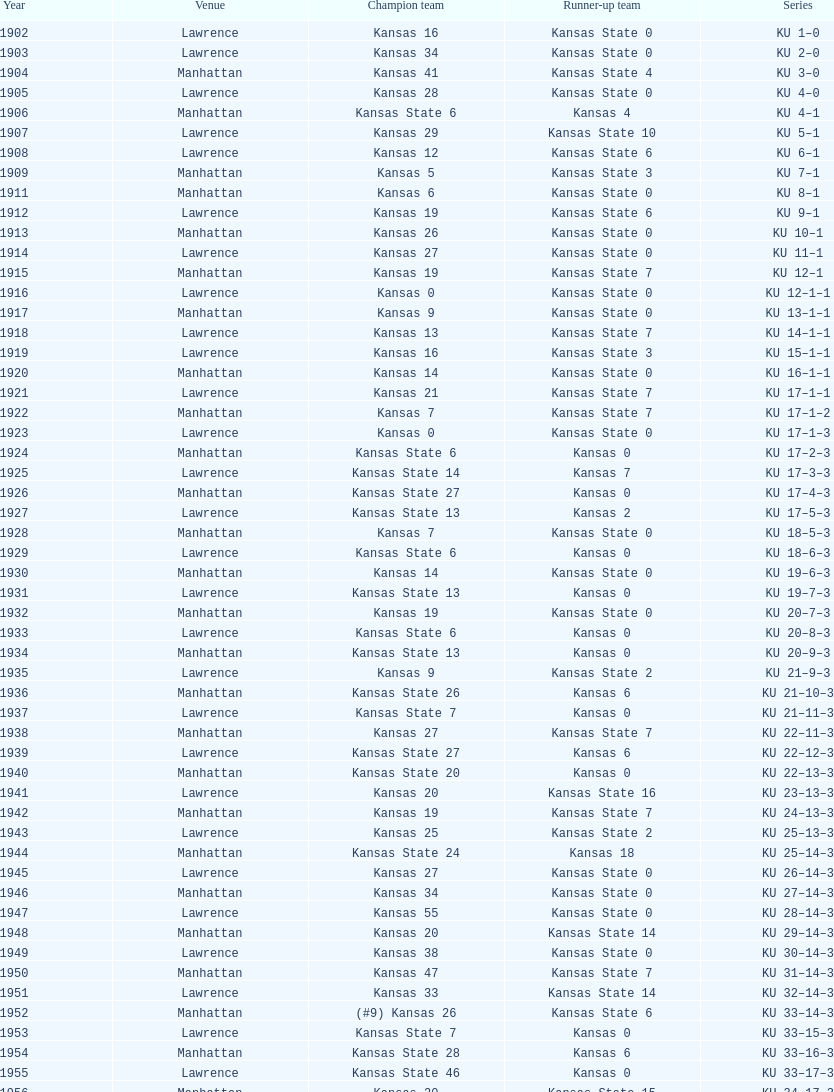Write the full table. {'header': ['Year', 'Venue', 'Champion team', 'Runner-up team', 'Series'], 'rows': [['1902', 'Lawrence', 'Kansas 16', 'Kansas State 0', 'KU 1–0'], ['1903', 'Lawrence', 'Kansas 34', 'Kansas State 0', 'KU 2–0'], ['1904', 'Manhattan', 'Kansas 41', 'Kansas State 4', 'KU 3–0'], ['1905', 'Lawrence', 'Kansas 28', 'Kansas State 0', 'KU 4–0'], ['1906', 'Manhattan', 'Kansas State 6', 'Kansas 4', 'KU 4–1'], ['1907', 'Lawrence', 'Kansas 29', 'Kansas State 10', 'KU 5–1'], ['1908', 'Lawrence', 'Kansas 12', 'Kansas State 6', 'KU 6–1'], ['1909', 'Manhattan', 'Kansas 5', 'Kansas State 3', 'KU 7–1'], ['1911', 'Manhattan', 'Kansas 6', 'Kansas State 0', 'KU 8–1'], ['1912', 'Lawrence', 'Kansas 19', 'Kansas State 6', 'KU 9–1'], ['1913', 'Manhattan', 'Kansas 26', 'Kansas State 0', 'KU 10–1'], ['1914', 'Lawrence', 'Kansas 27', 'Kansas State 0', 'KU 11–1'], ['1915', 'Manhattan', 'Kansas 19', 'Kansas State 7', 'KU 12–1'], ['1916', 'Lawrence', 'Kansas 0', 'Kansas State 0', 'KU 12–1–1'], ['1917', 'Manhattan', 'Kansas 9', 'Kansas State 0', 'KU 13–1–1'], ['1918', 'Lawrence', 'Kansas 13', 'Kansas State 7', 'KU 14–1–1'], ['1919', 'Lawrence', 'Kansas 16', 'Kansas State 3', 'KU 15–1–1'], ['1920', 'Manhattan', 'Kansas 14', 'Kansas State 0', 'KU 16–1–1'], ['1921', 'Lawrence', 'Kansas 21', 'Kansas State 7', 'KU 17–1–1'], ['1922', 'Manhattan', 'Kansas 7', 'Kansas State 7', 'KU 17–1–2'], ['1923', 'Lawrence', 'Kansas 0', 'Kansas State 0', 'KU 17–1–3'], ['1924', 'Manhattan', 'Kansas State 6', 'Kansas 0', 'KU 17–2–3'], ['1925', 'Lawrence', 'Kansas State 14', 'Kansas 7', 'KU 17–3–3'], ['1926', 'Manhattan', 'Kansas State 27', 'Kansas 0', 'KU 17–4–3'], ['1927', 'Lawrence', 'Kansas State 13', 'Kansas 2', 'KU 17–5–3'], ['1928', 'Manhattan', 'Kansas 7', 'Kansas State 0', 'KU 18–5–3'], ['1929', 'Lawrence', 'Kansas State 6', 'Kansas 0', 'KU 18–6–3'], ['1930', 'Manhattan', 'Kansas 14', 'Kansas State 0', 'KU 19–6–3'], ['1931', 'Lawrence', 'Kansas State 13', 'Kansas 0', 'KU 19–7–3'], ['1932', 'Manhattan', 'Kansas 19', 'Kansas State 0', 'KU 20–7–3'], ['1933', 'Lawrence', 'Kansas State 6', 'Kansas 0', 'KU 20–8–3'], ['1934', 'Manhattan', 'Kansas State 13', 'Kansas 0', 'KU 20–9–3'], ['1935', 'Lawrence', 'Kansas 9', 'Kansas State 2', 'KU 21–9–3'], ['1936', 'Manhattan', 'Kansas State 26', 'Kansas 6', 'KU 21–10–3'], ['1937', 'Lawrence', 'Kansas State 7', 'Kansas 0', 'KU 21–11–3'], ['1938', 'Manhattan', 'Kansas 27', 'Kansas State 7', 'KU 22–11–3'], ['1939', 'Lawrence', 'Kansas State 27', 'Kansas 6', 'KU 22–12–3'], ['1940', 'Manhattan', 'Kansas State 20', 'Kansas 0', 'KU 22–13–3'], ['1941', 'Lawrence', 'Kansas 20', 'Kansas State 16', 'KU 23–13–3'], ['1942', 'Manhattan', 'Kansas 19', 'Kansas State 7', 'KU 24–13–3'], ['1943', 'Lawrence', 'Kansas 25', 'Kansas State 2', 'KU 25–13–3'], ['1944', 'Manhattan', 'Kansas State 24', 'Kansas 18', 'KU 25–14–3'], ['1945', 'Lawrence', 'Kansas 27', 'Kansas State 0', 'KU 26–14–3'], ['1946', 'Manhattan', 'Kansas 34', 'Kansas State 0', 'KU 27–14–3'], ['1947', 'Lawrence', 'Kansas 55', 'Kansas State 0', 'KU 28–14–3'], ['1948', 'Manhattan', 'Kansas 20', 'Kansas State 14', 'KU 29–14–3'], ['1949', 'Lawrence', 'Kansas 38', 'Kansas State 0', 'KU 30–14–3'], ['1950', 'Manhattan', 'Kansas 47', 'Kansas State 7', 'KU 31–14–3'], ['1951', 'Lawrence', 'Kansas 33', 'Kansas State 14', 'KU 32–14–3'], ['1952', 'Manhattan', '(#9) Kansas 26', 'Kansas State 6', 'KU 33–14–3'], ['1953', 'Lawrence', 'Kansas State 7', 'Kansas 0', 'KU 33–15–3'], ['1954', 'Manhattan', 'Kansas State 28', 'Kansas 6', 'KU 33–16–3'], ['1955', 'Lawrence', 'Kansas State 46', 'Kansas 0', 'KU 33–17–3'], ['1956', 'Manhattan', 'Kansas 20', 'Kansas State 15', 'KU 34–17–3'], ['1957', 'Lawrence', 'Kansas 13', 'Kansas State 7', 'KU 35–17–3'], ['1958', 'Manhattan', 'Kansas 21', 'Kansas State 12', 'KU 36–17–3'], ['1959', 'Lawrence', 'Kansas 33', 'Kansas State 14', 'KU 37–17–3'], ['1960', 'Manhattan', 'Kansas 41', 'Kansas State 0', 'KU 38–17–3'], ['1961', 'Lawrence', 'Kansas 34', 'Kansas State 0', 'KU 39–17–3'], ['1962', 'Manhattan', 'Kansas 38', 'Kansas State 0', 'KU 40–17–3'], ['1963', 'Lawrence', 'Kansas 34', 'Kansas State 0', 'KU 41–17–3'], ['1964', 'Manhattan', 'Kansas 7', 'Kansas State 0', 'KU 42–17–3'], ['1965', 'Lawrence', 'Kansas 34', 'Kansas State 0', 'KU 43–17–3'], ['1966', 'Manhattan', 'Kansas 3', 'Kansas State 3', 'KU 43–17–4'], ['1967', 'Lawrence', 'Kansas 17', 'Kansas State 16', 'KU 44–17–4'], ['1968', 'Manhattan', '(#7) Kansas 38', 'Kansas State 29', 'KU 45–17–4']]} In manhattan, what was the quantity of kansas state's successful games? 8. 